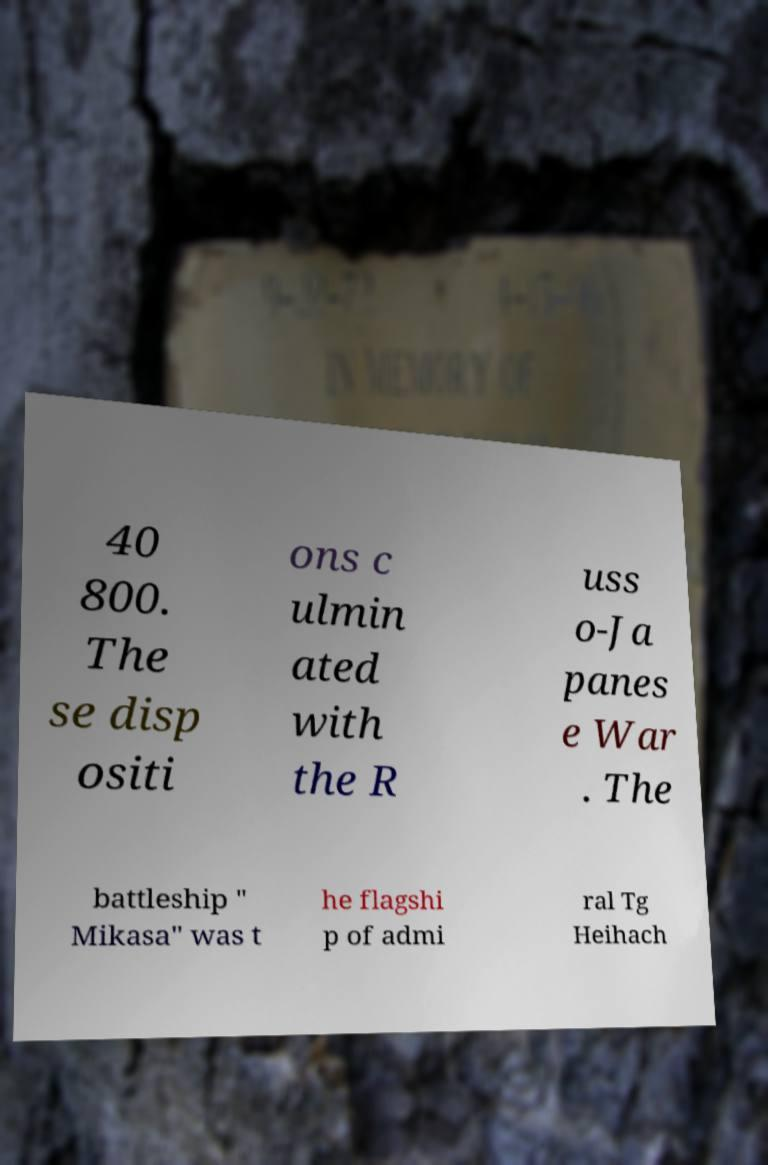For documentation purposes, I need the text within this image transcribed. Could you provide that? 40 800. The se disp ositi ons c ulmin ated with the R uss o-Ja panes e War . The battleship " Mikasa" was t he flagshi p of admi ral Tg Heihach 